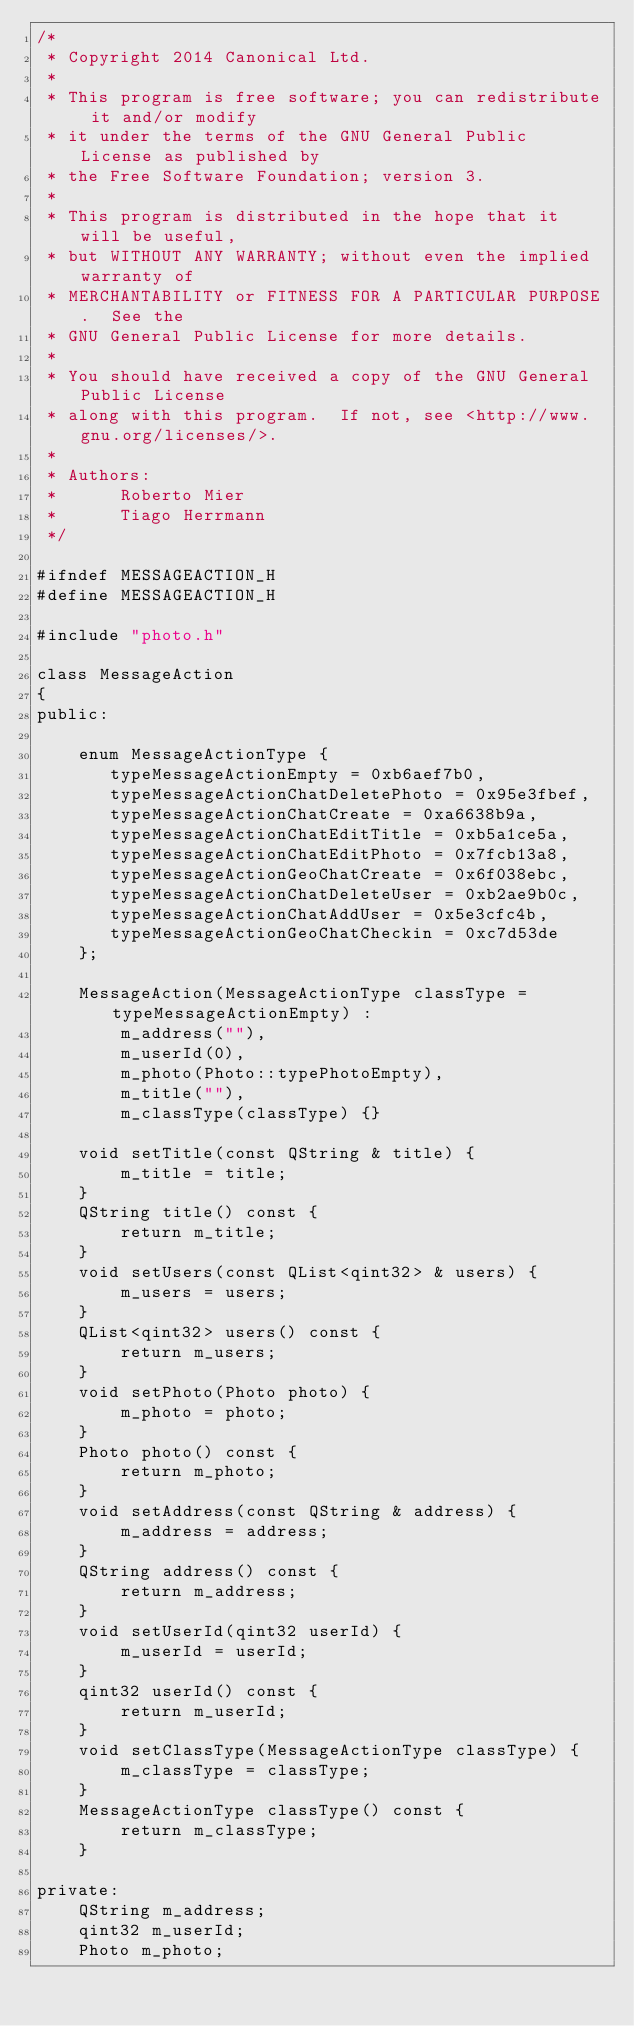<code> <loc_0><loc_0><loc_500><loc_500><_C_>/*
 * Copyright 2014 Canonical Ltd.
 *
 * This program is free software; you can redistribute it and/or modify
 * it under the terms of the GNU General Public License as published by
 * the Free Software Foundation; version 3.
 *
 * This program is distributed in the hope that it will be useful,
 * but WITHOUT ANY WARRANTY; without even the implied warranty of
 * MERCHANTABILITY or FITNESS FOR A PARTICULAR PURPOSE.  See the
 * GNU General Public License for more details.
 *
 * You should have received a copy of the GNU General Public License
 * along with this program.  If not, see <http://www.gnu.org/licenses/>.
 *
 * Authors:
 *      Roberto Mier
 *      Tiago Herrmann
 */

#ifndef MESSAGEACTION_H
#define MESSAGEACTION_H

#include "photo.h"

class MessageAction
{
public:

    enum MessageActionType {
       typeMessageActionEmpty = 0xb6aef7b0,
       typeMessageActionChatDeletePhoto = 0x95e3fbef,
       typeMessageActionChatCreate = 0xa6638b9a,
       typeMessageActionChatEditTitle = 0xb5a1ce5a,
       typeMessageActionChatEditPhoto = 0x7fcb13a8,
       typeMessageActionGeoChatCreate = 0x6f038ebc,
       typeMessageActionChatDeleteUser = 0xb2ae9b0c,
       typeMessageActionChatAddUser = 0x5e3cfc4b,
       typeMessageActionGeoChatCheckin = 0xc7d53de
    };

    MessageAction(MessageActionType classType = typeMessageActionEmpty) :
        m_address(""),
        m_userId(0),
        m_photo(Photo::typePhotoEmpty),
        m_title(""),
        m_classType(classType) {}

    void setTitle(const QString & title) {
        m_title = title;
    }
    QString title() const {
        return m_title;
    }
    void setUsers(const QList<qint32> & users) {
        m_users = users;
    }
    QList<qint32> users() const {
        return m_users;
    }
    void setPhoto(Photo photo) {
        m_photo = photo;
    }
    Photo photo() const {
        return m_photo;
    }
    void setAddress(const QString & address) {
        m_address = address;
    }
    QString address() const {
        return m_address;
    }
    void setUserId(qint32 userId) {
        m_userId = userId;
    }
    qint32 userId() const {
        return m_userId;
    }
    void setClassType(MessageActionType classType) {
        m_classType = classType;
    }
    MessageActionType classType() const {
        return m_classType;
    }

private:
    QString m_address;
    qint32 m_userId;
    Photo m_photo;</code> 